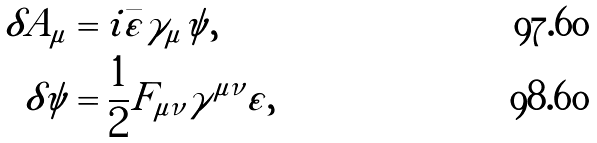Convert formula to latex. <formula><loc_0><loc_0><loc_500><loc_500>\delta A _ { \mu } & = i \bar { \varepsilon } \gamma _ { \mu } \psi , \\ \delta \psi & = \frac { 1 } { 2 } F _ { \mu \nu } \gamma ^ { \mu \nu } \varepsilon ,</formula> 